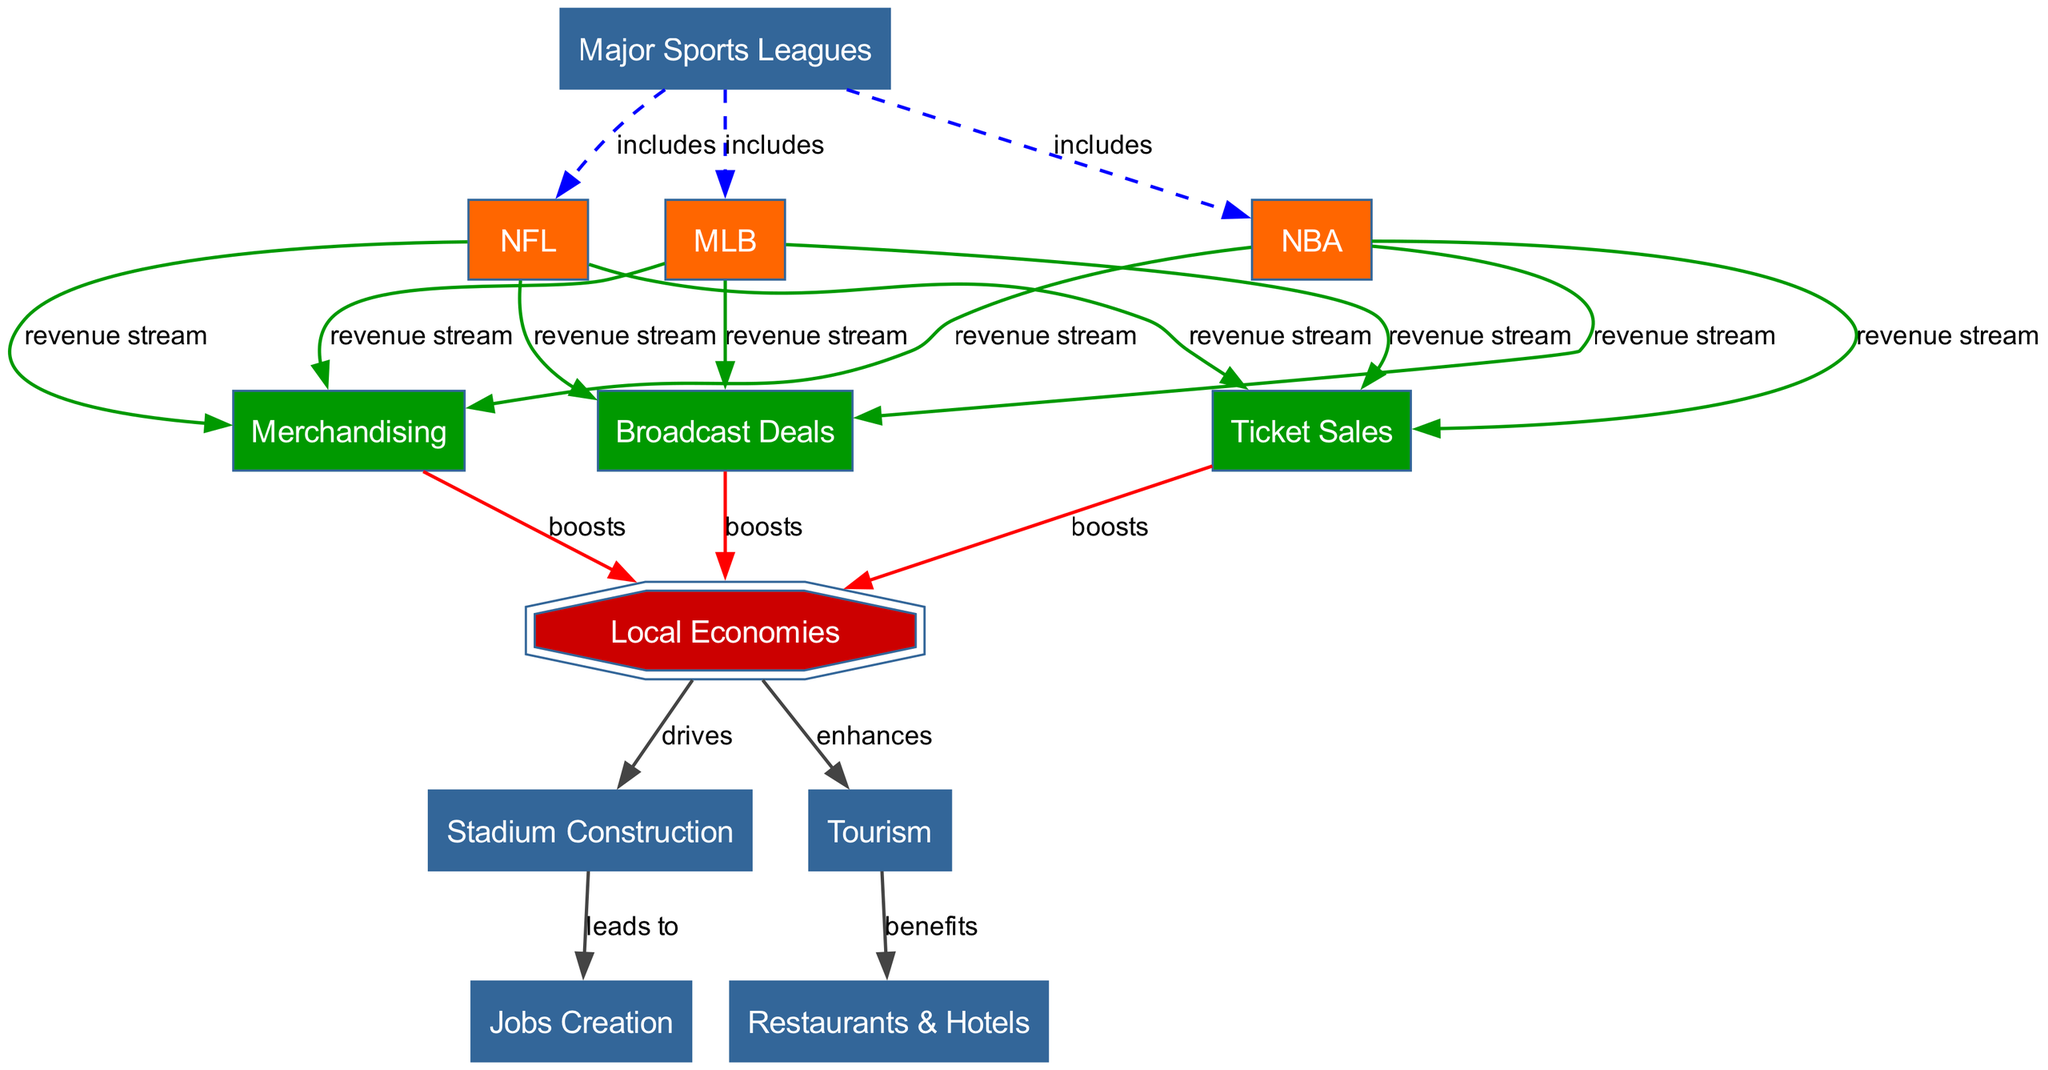What are the three major sports leagues represented? The diagram lists the NFL, NBA, and MLB as the major sports leagues included. These leagues are explicitly connected to the main node "Major Sports Leagues" with "includes" as the relationship label.
Answer: NFL, NBA, MLB How many revenue streams are shown in the diagram? The diagram includes three revenue streams: Merchandising, Ticket Sales, and Broadcast Deals, as indicated by the connections which label these as "revenue stream" from NFL, NBA, and MLB.
Answer: 3 Which node indicates the impact of local economies? The node labeled "Local Economies" stands out because it has multiple incoming arrows indicating that it is influenced by different revenue streams, as well as leading to other outcomes like Stadium Construction and Tourism, emphasizing its significance in the economic impact.
Answer: Local Economies What is the connection between Local Economies and Stadium Construction? The connection is indicated as "drives" from Local Economies to Stadium Construction. This means that as local economies improve, they stimulate or drive the construction of new stadiums, which can further enhance economic activity.
Answer: drives Which aspect benefits from Tourism according to the diagram? The diagram shows that Tourism enhances "Restaurants & Hotels," meaning that increased tourism leads to greater business for restaurants and hotels in the area, indicating its economic benefit.
Answer: Restaurants & Hotels Which leagues contribute to both Ticket Sales and Broadcast Deals? All three leagues—the NFL, NBA, and MLB—contribute to both Ticket Sales and Broadcast Deals, as indicated by the direct "revenue stream" connections from each league to those specific nodes.
Answer: NFL, NBA, MLB How does Stadium Construction lead to another economic benefit? The diagram indicates that Stadium Construction leads to "Jobs Creation." This is represented by an arrow labeled "leads to" connecting Stadium Construction to Jobs Creation, highlighting how building stadiums directly creates job opportunities.
Answer: Jobs Creation What types of revenue streams can be derived from Major Sports Leagues? The revenue streams derived from Major Sports Leagues include Merchandising, Ticket Sales, and Broadcast Deals, as each of these nodes is directly connected to the major leagues with the label "revenue stream."
Answer: Merchandising, Ticket Sales, Broadcast Deals What is the relationship between Broadcast Deals and Local Economies? The relationship is labeled "boosts," indicating that Broadcast Deals positively impact Local Economies by increasing economic activity and revenues within the local area.
Answer: boosts 